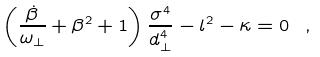Convert formula to latex. <formula><loc_0><loc_0><loc_500><loc_500>\left ( \frac { \dot { \beta } } { \omega _ { \perp } } + \beta ^ { 2 } + 1 \right ) \frac { \sigma ^ { 4 } } { d _ { \perp } ^ { 4 } } - l ^ { 2 } - \kappa = 0 \ ,</formula> 